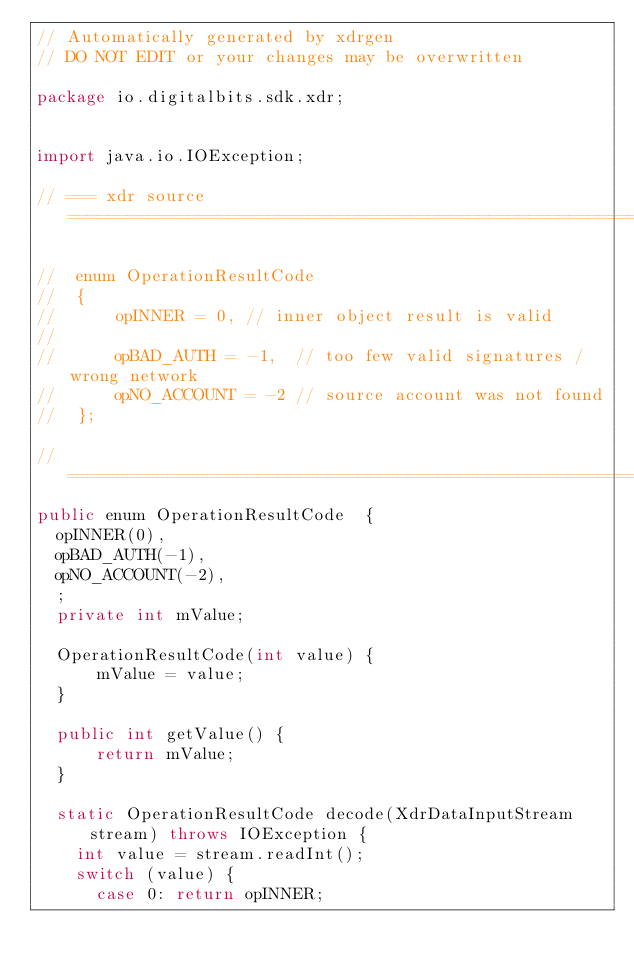Convert code to text. <code><loc_0><loc_0><loc_500><loc_500><_Java_>// Automatically generated by xdrgen 
// DO NOT EDIT or your changes may be overwritten

package io.digitalbits.sdk.xdr;


import java.io.IOException;

// === xdr source ============================================================

//  enum OperationResultCode
//  {
//      opINNER = 0, // inner object result is valid
//  
//      opBAD_AUTH = -1,  // too few valid signatures / wrong network
//      opNO_ACCOUNT = -2 // source account was not found
//  };

//  ===========================================================================
public enum OperationResultCode  {
  opINNER(0),
  opBAD_AUTH(-1),
  opNO_ACCOUNT(-2),
  ;
  private int mValue;

  OperationResultCode(int value) {
      mValue = value;
  }

  public int getValue() {
      return mValue;
  }

  static OperationResultCode decode(XdrDataInputStream stream) throws IOException {
    int value = stream.readInt();
    switch (value) {
      case 0: return opINNER;</code> 